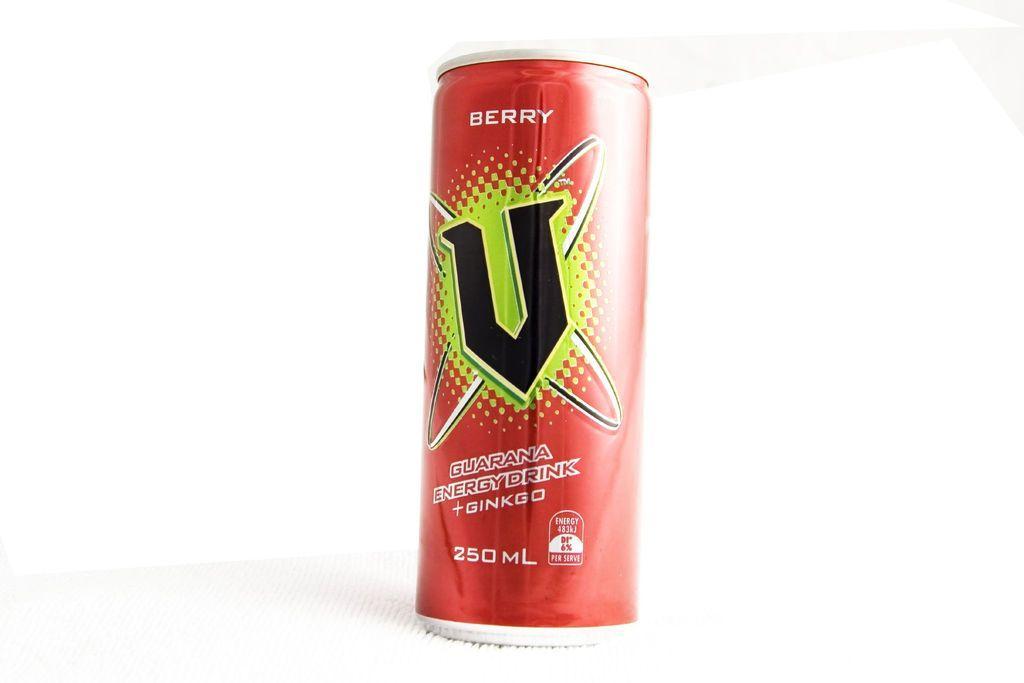How would you summarize this image in a sentence or two? In this image I can see the tin in red, green and black color and something is written on it. Background is in white color. 